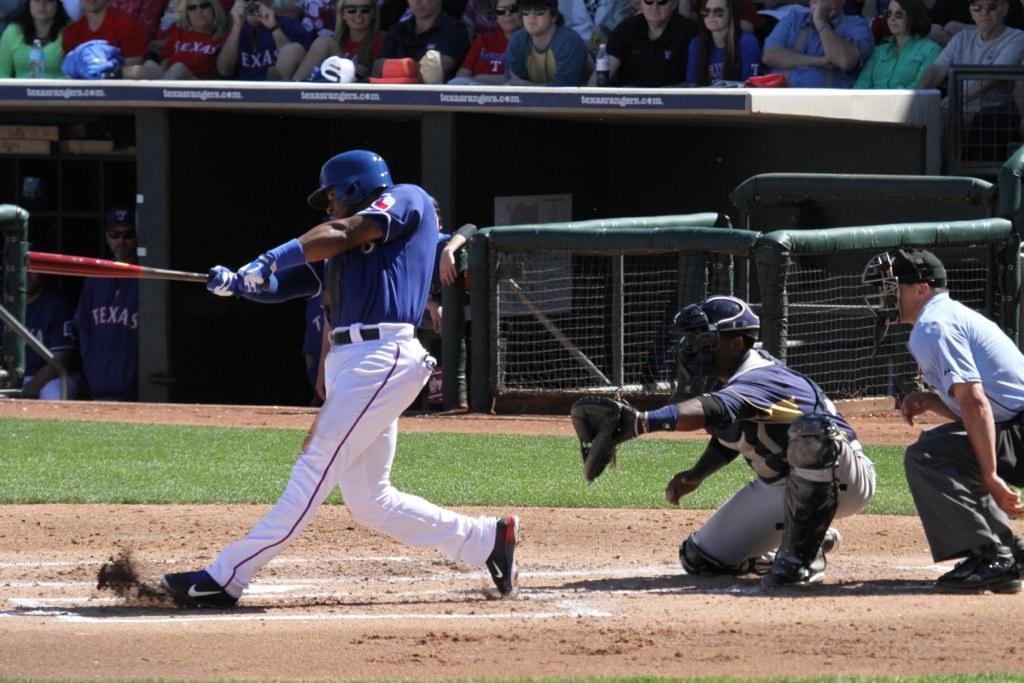<image>
Create a compact narrative representing the image presented. A baseball player for Texas is swinging at a pitch. 